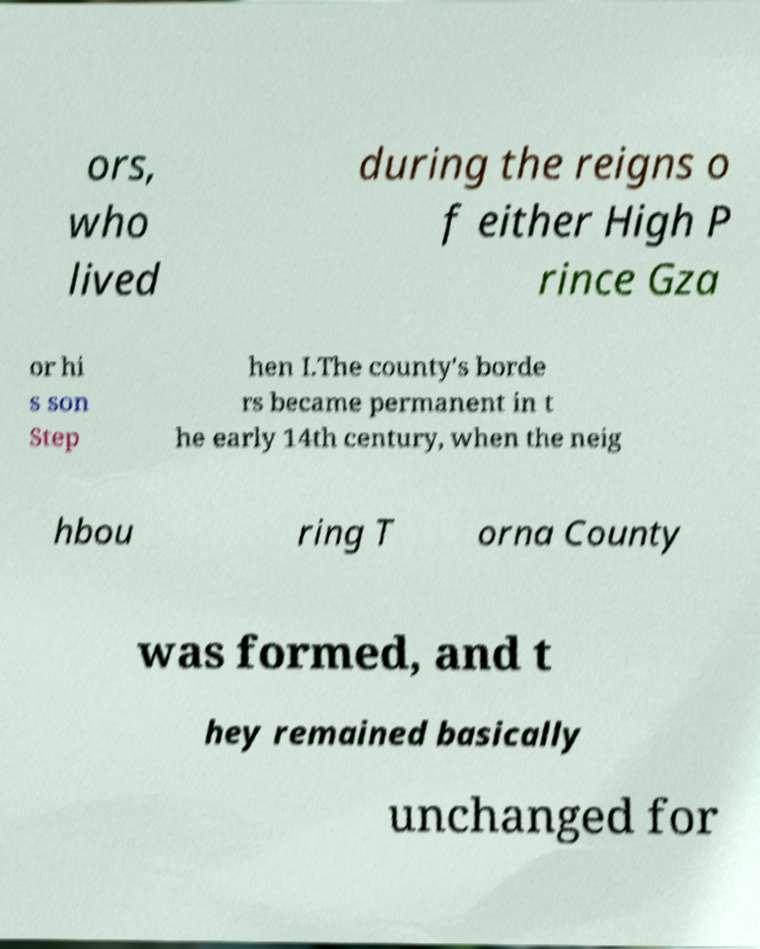For documentation purposes, I need the text within this image transcribed. Could you provide that? ors, who lived during the reigns o f either High P rince Gza or hi s son Step hen I.The county's borde rs became permanent in t he early 14th century, when the neig hbou ring T orna County was formed, and t hey remained basically unchanged for 